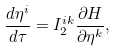Convert formula to latex. <formula><loc_0><loc_0><loc_500><loc_500>\frac { d { \eta } ^ { i } } { d \tau } = I _ { 2 } ^ { i k } \frac { \partial { H } } { \partial { \eta } ^ { k } } ,</formula> 